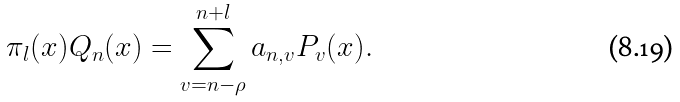<formula> <loc_0><loc_0><loc_500><loc_500>\pi _ { l } ( x ) Q _ { n } ( x ) & = \sum _ { v = n - \rho } ^ { n + l } a _ { n , v } P _ { v } ( x ) .</formula> 